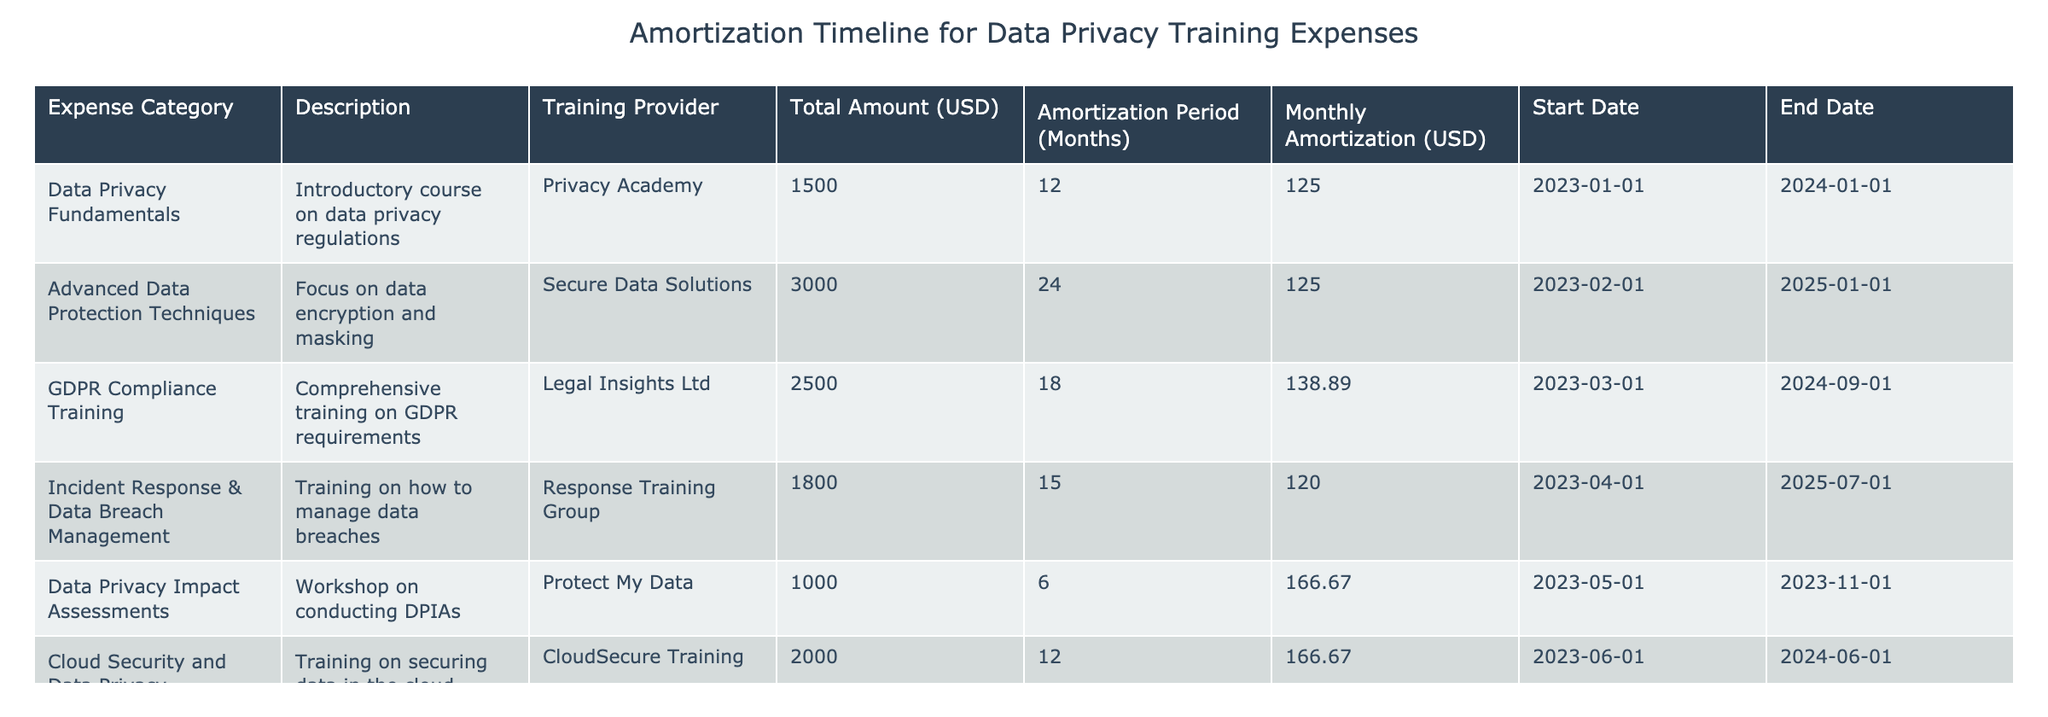What is the total amount of expenses for training on data privacy best practices? To find the total amount of expenses, we sum the 'Total Amount (USD)' column. The amounts are 1500, 3000, 2500, 1800, 1000, 2000, 2200, and 1600. The total is 1500 + 3000 + 2500 + 1800 + 1000 + 2000 + 2200 + 1600 = 14600.
Answer: 14600 Which training provider offers the most expensive training course? We look for the maximum value in the 'Total Amount (USD)' column. The maximum value is 3000, which corresponds to 'Secure Data Solutions'.
Answer: Secure Data Solutions What training course has the longest amortization period? We check the 'Amortization Period (Months)' column for the maximum value. The longest period is 24 months, which corresponds to the 'Advanced Data Protection Techniques' course.
Answer: Advanced Data Protection Techniques Is there a training course that has no overlap in the amortization timeline with any other courses? We need to check the start and end dates to assess overlaps. The 'Data Privacy Impact Assessments' course runs from 2023-05-01 to 2023-11-01, and it overlaps with courses starting in 2023, so there is no course without any overlap.
Answer: No What is the average monthly amortization cost across all training courses? We calculate the average by summing all monthly amortizations: 125 + 125 + 138.89 + 120 + 166.67 + 166.67 + 110 + 133.33 = 1,086.56. There are 8 courses, so the average is 1,086.56 / 8 = 135.82.
Answer: 135.82 Which course has the shortest amortization period, and what is its duration? In the 'Amortization Period (Months)' column, the minimum value is 6 months, corresponding to the 'Data Privacy Impact Assessments' training.
Answer: Data Privacy Impact Assessments, 6 months How many training courses have duration less than 12 months? We check the 'Amortization Period (Months)' column for values less than 12. Only 'Data Privacy Impact Assessments' (6 months) and 'Data Privacy Fundamentals' (12 months) qualify. Hence there is 1 course.
Answer: 1 What is the total amortization cost for training courses that focus specifically on data protection and compliance? We identify relevant courses: 'Advanced Data Protection Techniques' (3000), 'GDPR Compliance Training' (2500), and 'Compliance Frameworks' (2200). Summing these gives 3000 + 2500 + 2200 = 7700.
Answer: 7700 Do any training providers offer courses that cover both data privacy fundamentals and incident response? We evaluate the 'Training Provider' related to 'Data Privacy Fundamentals' (Privacy Academy) and 'Incident Response & Data Breach Management' (Response Training Group). They are different, indicating no provider covers both.
Answer: No 